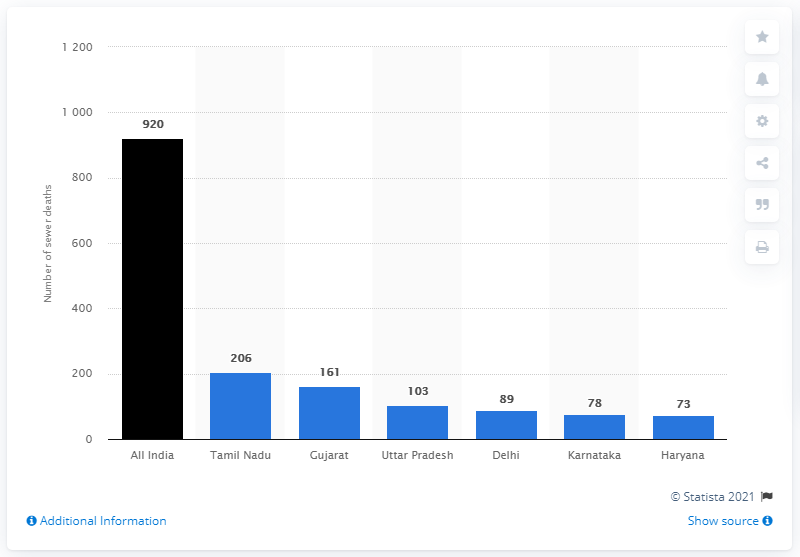Indicate a few pertinent items in this graphic. Tamil Nadu had the highest number of sewer deaths among all states in India. According to a study conducted between 1993 and 2010, a total of 920 individuals died while cleaning sewers and septic tanks. 